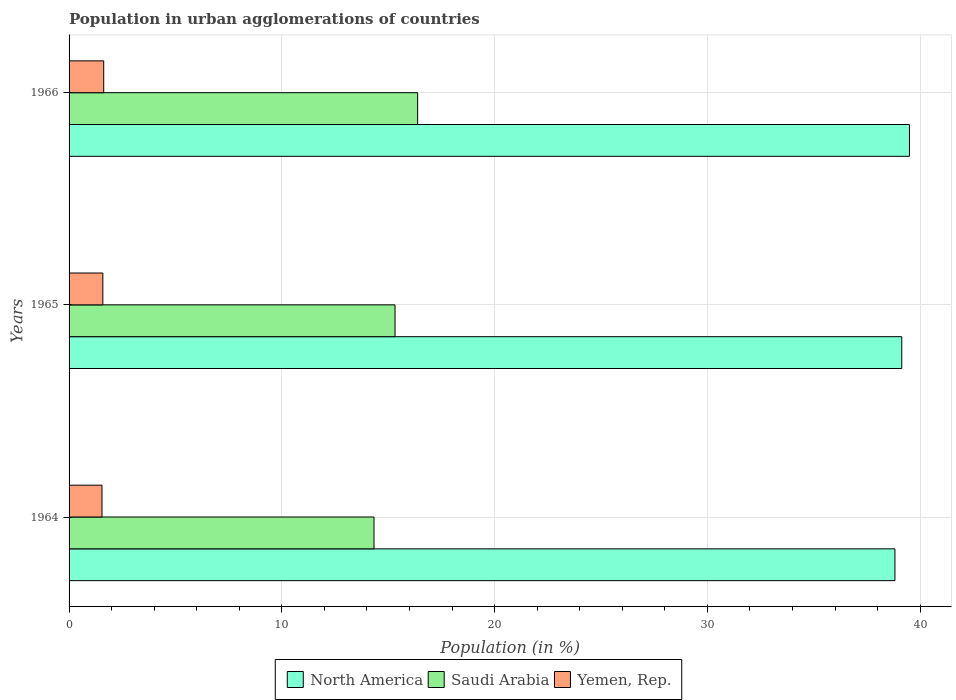How many groups of bars are there?
Offer a very short reply. 3. What is the label of the 1st group of bars from the top?
Your answer should be very brief. 1966. What is the percentage of population in urban agglomerations in Saudi Arabia in 1964?
Offer a very short reply. 14.33. Across all years, what is the maximum percentage of population in urban agglomerations in Yemen, Rep.?
Give a very brief answer. 1.63. Across all years, what is the minimum percentage of population in urban agglomerations in Saudi Arabia?
Your response must be concise. 14.33. In which year was the percentage of population in urban agglomerations in Yemen, Rep. maximum?
Provide a succinct answer. 1966. In which year was the percentage of population in urban agglomerations in North America minimum?
Make the answer very short. 1964. What is the total percentage of population in urban agglomerations in North America in the graph?
Offer a terse response. 117.45. What is the difference between the percentage of population in urban agglomerations in Yemen, Rep. in 1964 and that in 1965?
Offer a terse response. -0.04. What is the difference between the percentage of population in urban agglomerations in North America in 1966 and the percentage of population in urban agglomerations in Saudi Arabia in 1964?
Provide a short and direct response. 25.17. What is the average percentage of population in urban agglomerations in North America per year?
Offer a terse response. 39.15. In the year 1965, what is the difference between the percentage of population in urban agglomerations in Saudi Arabia and percentage of population in urban agglomerations in Yemen, Rep.?
Your response must be concise. 13.73. What is the ratio of the percentage of population in urban agglomerations in North America in 1964 to that in 1966?
Provide a succinct answer. 0.98. Is the difference between the percentage of population in urban agglomerations in Saudi Arabia in 1964 and 1965 greater than the difference between the percentage of population in urban agglomerations in Yemen, Rep. in 1964 and 1965?
Offer a very short reply. No. What is the difference between the highest and the second highest percentage of population in urban agglomerations in North America?
Keep it short and to the point. 0.36. What is the difference between the highest and the lowest percentage of population in urban agglomerations in North America?
Your answer should be very brief. 0.68. In how many years, is the percentage of population in urban agglomerations in Yemen, Rep. greater than the average percentage of population in urban agglomerations in Yemen, Rep. taken over all years?
Your response must be concise. 1. What does the 1st bar from the top in 1965 represents?
Your answer should be very brief. Yemen, Rep. What does the 2nd bar from the bottom in 1965 represents?
Provide a succinct answer. Saudi Arabia. Is it the case that in every year, the sum of the percentage of population in urban agglomerations in Saudi Arabia and percentage of population in urban agglomerations in Yemen, Rep. is greater than the percentage of population in urban agglomerations in North America?
Your answer should be very brief. No. How many years are there in the graph?
Your answer should be compact. 3. Where does the legend appear in the graph?
Your response must be concise. Bottom center. How many legend labels are there?
Offer a very short reply. 3. How are the legend labels stacked?
Give a very brief answer. Horizontal. What is the title of the graph?
Your answer should be very brief. Population in urban agglomerations of countries. What is the Population (in %) in North America in 1964?
Your answer should be compact. 38.82. What is the Population (in %) of Saudi Arabia in 1964?
Give a very brief answer. 14.33. What is the Population (in %) in Yemen, Rep. in 1964?
Give a very brief answer. 1.55. What is the Population (in %) of North America in 1965?
Offer a very short reply. 39.14. What is the Population (in %) in Saudi Arabia in 1965?
Give a very brief answer. 15.32. What is the Population (in %) in Yemen, Rep. in 1965?
Your answer should be very brief. 1.59. What is the Population (in %) of North America in 1966?
Your answer should be very brief. 39.5. What is the Population (in %) of Saudi Arabia in 1966?
Offer a very short reply. 16.38. What is the Population (in %) of Yemen, Rep. in 1966?
Your answer should be very brief. 1.63. Across all years, what is the maximum Population (in %) of North America?
Offer a terse response. 39.5. Across all years, what is the maximum Population (in %) in Saudi Arabia?
Provide a succinct answer. 16.38. Across all years, what is the maximum Population (in %) of Yemen, Rep.?
Provide a short and direct response. 1.63. Across all years, what is the minimum Population (in %) of North America?
Your answer should be compact. 38.82. Across all years, what is the minimum Population (in %) in Saudi Arabia?
Your answer should be compact. 14.33. Across all years, what is the minimum Population (in %) of Yemen, Rep.?
Offer a very short reply. 1.55. What is the total Population (in %) of North America in the graph?
Keep it short and to the point. 117.45. What is the total Population (in %) of Saudi Arabia in the graph?
Provide a short and direct response. 46.04. What is the total Population (in %) in Yemen, Rep. in the graph?
Offer a very short reply. 4.76. What is the difference between the Population (in %) of North America in 1964 and that in 1965?
Provide a succinct answer. -0.32. What is the difference between the Population (in %) of Saudi Arabia in 1964 and that in 1965?
Provide a short and direct response. -0.99. What is the difference between the Population (in %) of Yemen, Rep. in 1964 and that in 1965?
Ensure brevity in your answer.  -0.04. What is the difference between the Population (in %) of North America in 1964 and that in 1966?
Provide a short and direct response. -0.68. What is the difference between the Population (in %) in Saudi Arabia in 1964 and that in 1966?
Ensure brevity in your answer.  -2.05. What is the difference between the Population (in %) in Yemen, Rep. in 1964 and that in 1966?
Give a very brief answer. -0.08. What is the difference between the Population (in %) in North America in 1965 and that in 1966?
Give a very brief answer. -0.36. What is the difference between the Population (in %) in Saudi Arabia in 1965 and that in 1966?
Offer a very short reply. -1.06. What is the difference between the Population (in %) in Yemen, Rep. in 1965 and that in 1966?
Your answer should be compact. -0.04. What is the difference between the Population (in %) of North America in 1964 and the Population (in %) of Saudi Arabia in 1965?
Provide a short and direct response. 23.5. What is the difference between the Population (in %) in North America in 1964 and the Population (in %) in Yemen, Rep. in 1965?
Your response must be concise. 37.23. What is the difference between the Population (in %) of Saudi Arabia in 1964 and the Population (in %) of Yemen, Rep. in 1965?
Provide a short and direct response. 12.75. What is the difference between the Population (in %) of North America in 1964 and the Population (in %) of Saudi Arabia in 1966?
Offer a terse response. 22.43. What is the difference between the Population (in %) in North America in 1964 and the Population (in %) in Yemen, Rep. in 1966?
Your answer should be very brief. 37.19. What is the difference between the Population (in %) in Saudi Arabia in 1964 and the Population (in %) in Yemen, Rep. in 1966?
Your response must be concise. 12.71. What is the difference between the Population (in %) of North America in 1965 and the Population (in %) of Saudi Arabia in 1966?
Keep it short and to the point. 22.75. What is the difference between the Population (in %) of North America in 1965 and the Population (in %) of Yemen, Rep. in 1966?
Give a very brief answer. 37.51. What is the difference between the Population (in %) of Saudi Arabia in 1965 and the Population (in %) of Yemen, Rep. in 1966?
Provide a short and direct response. 13.69. What is the average Population (in %) of North America per year?
Provide a succinct answer. 39.15. What is the average Population (in %) of Saudi Arabia per year?
Your answer should be very brief. 15.35. What is the average Population (in %) of Yemen, Rep. per year?
Make the answer very short. 1.59. In the year 1964, what is the difference between the Population (in %) in North America and Population (in %) in Saudi Arabia?
Your answer should be very brief. 24.48. In the year 1964, what is the difference between the Population (in %) of North America and Population (in %) of Yemen, Rep.?
Offer a very short reply. 37.27. In the year 1964, what is the difference between the Population (in %) of Saudi Arabia and Population (in %) of Yemen, Rep.?
Offer a terse response. 12.79. In the year 1965, what is the difference between the Population (in %) of North America and Population (in %) of Saudi Arabia?
Your answer should be compact. 23.82. In the year 1965, what is the difference between the Population (in %) of North America and Population (in %) of Yemen, Rep.?
Keep it short and to the point. 37.55. In the year 1965, what is the difference between the Population (in %) in Saudi Arabia and Population (in %) in Yemen, Rep.?
Offer a terse response. 13.73. In the year 1966, what is the difference between the Population (in %) in North America and Population (in %) in Saudi Arabia?
Your answer should be very brief. 23.12. In the year 1966, what is the difference between the Population (in %) of North America and Population (in %) of Yemen, Rep.?
Provide a succinct answer. 37.87. In the year 1966, what is the difference between the Population (in %) of Saudi Arabia and Population (in %) of Yemen, Rep.?
Ensure brevity in your answer.  14.76. What is the ratio of the Population (in %) of North America in 1964 to that in 1965?
Provide a short and direct response. 0.99. What is the ratio of the Population (in %) of Saudi Arabia in 1964 to that in 1965?
Offer a very short reply. 0.94. What is the ratio of the Population (in %) of Yemen, Rep. in 1964 to that in 1965?
Offer a very short reply. 0.97. What is the ratio of the Population (in %) of North America in 1964 to that in 1966?
Keep it short and to the point. 0.98. What is the ratio of the Population (in %) in Saudi Arabia in 1964 to that in 1966?
Provide a short and direct response. 0.87. What is the ratio of the Population (in %) in Yemen, Rep. in 1964 to that in 1966?
Offer a very short reply. 0.95. What is the ratio of the Population (in %) in Saudi Arabia in 1965 to that in 1966?
Your response must be concise. 0.94. What is the ratio of the Population (in %) in Yemen, Rep. in 1965 to that in 1966?
Provide a succinct answer. 0.98. What is the difference between the highest and the second highest Population (in %) of North America?
Give a very brief answer. 0.36. What is the difference between the highest and the second highest Population (in %) in Saudi Arabia?
Your answer should be very brief. 1.06. What is the difference between the highest and the second highest Population (in %) of Yemen, Rep.?
Ensure brevity in your answer.  0.04. What is the difference between the highest and the lowest Population (in %) in North America?
Make the answer very short. 0.68. What is the difference between the highest and the lowest Population (in %) of Saudi Arabia?
Your response must be concise. 2.05. What is the difference between the highest and the lowest Population (in %) of Yemen, Rep.?
Provide a short and direct response. 0.08. 